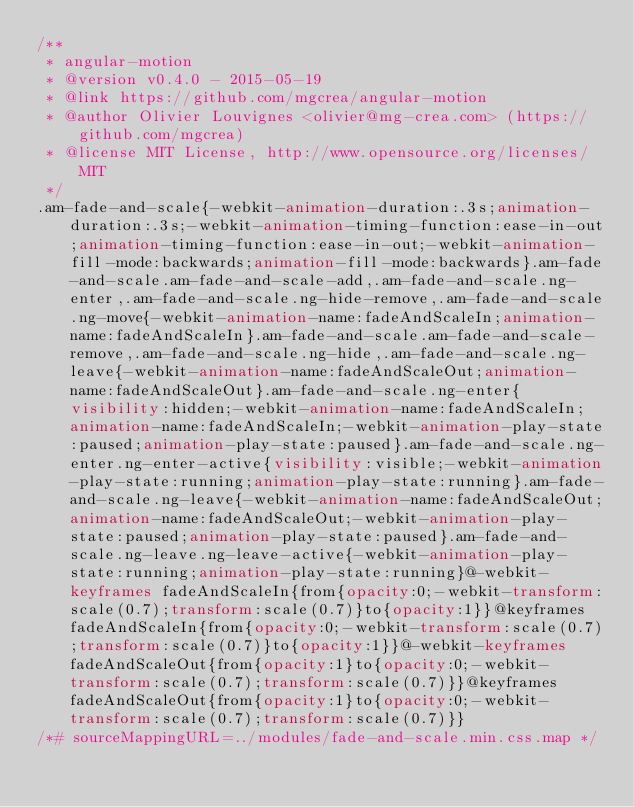Convert code to text. <code><loc_0><loc_0><loc_500><loc_500><_CSS_>/**
 * angular-motion
 * @version v0.4.0 - 2015-05-19
 * @link https://github.com/mgcrea/angular-motion
 * @author Olivier Louvignes <olivier@mg-crea.com> (https://github.com/mgcrea)
 * @license MIT License, http://www.opensource.org/licenses/MIT
 */
.am-fade-and-scale{-webkit-animation-duration:.3s;animation-duration:.3s;-webkit-animation-timing-function:ease-in-out;animation-timing-function:ease-in-out;-webkit-animation-fill-mode:backwards;animation-fill-mode:backwards}.am-fade-and-scale.am-fade-and-scale-add,.am-fade-and-scale.ng-enter,.am-fade-and-scale.ng-hide-remove,.am-fade-and-scale.ng-move{-webkit-animation-name:fadeAndScaleIn;animation-name:fadeAndScaleIn}.am-fade-and-scale.am-fade-and-scale-remove,.am-fade-and-scale.ng-hide,.am-fade-and-scale.ng-leave{-webkit-animation-name:fadeAndScaleOut;animation-name:fadeAndScaleOut}.am-fade-and-scale.ng-enter{visibility:hidden;-webkit-animation-name:fadeAndScaleIn;animation-name:fadeAndScaleIn;-webkit-animation-play-state:paused;animation-play-state:paused}.am-fade-and-scale.ng-enter.ng-enter-active{visibility:visible;-webkit-animation-play-state:running;animation-play-state:running}.am-fade-and-scale.ng-leave{-webkit-animation-name:fadeAndScaleOut;animation-name:fadeAndScaleOut;-webkit-animation-play-state:paused;animation-play-state:paused}.am-fade-and-scale.ng-leave.ng-leave-active{-webkit-animation-play-state:running;animation-play-state:running}@-webkit-keyframes fadeAndScaleIn{from{opacity:0;-webkit-transform:scale(0.7);transform:scale(0.7)}to{opacity:1}}@keyframes fadeAndScaleIn{from{opacity:0;-webkit-transform:scale(0.7);transform:scale(0.7)}to{opacity:1}}@-webkit-keyframes fadeAndScaleOut{from{opacity:1}to{opacity:0;-webkit-transform:scale(0.7);transform:scale(0.7)}}@keyframes fadeAndScaleOut{from{opacity:1}to{opacity:0;-webkit-transform:scale(0.7);transform:scale(0.7)}}
/*# sourceMappingURL=../modules/fade-and-scale.min.css.map */</code> 